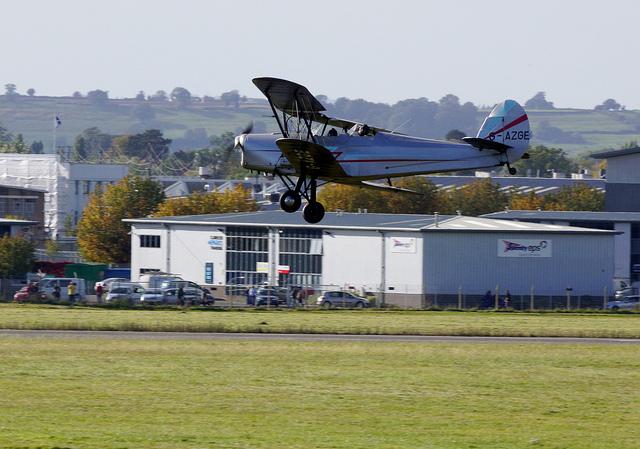How many wheels are on the ground?
Answer briefly. 0. Is the plane landing?
Keep it brief. Yes. Is the plane in motion?
Be succinct. Yes. 